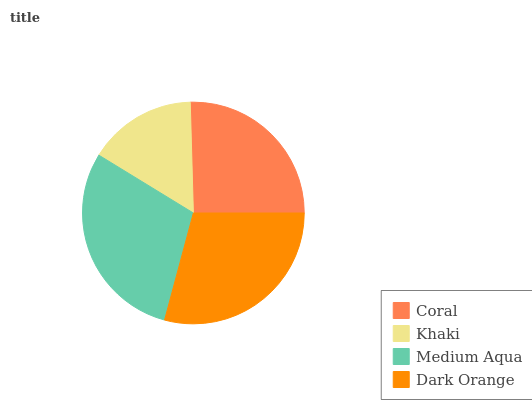Is Khaki the minimum?
Answer yes or no. Yes. Is Medium Aqua the maximum?
Answer yes or no. Yes. Is Medium Aqua the minimum?
Answer yes or no. No. Is Khaki the maximum?
Answer yes or no. No. Is Medium Aqua greater than Khaki?
Answer yes or no. Yes. Is Khaki less than Medium Aqua?
Answer yes or no. Yes. Is Khaki greater than Medium Aqua?
Answer yes or no. No. Is Medium Aqua less than Khaki?
Answer yes or no. No. Is Dark Orange the high median?
Answer yes or no. Yes. Is Coral the low median?
Answer yes or no. Yes. Is Medium Aqua the high median?
Answer yes or no. No. Is Medium Aqua the low median?
Answer yes or no. No. 